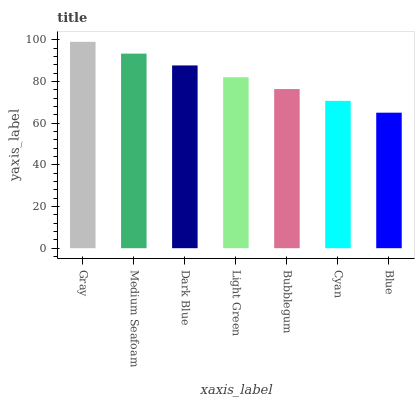Is Medium Seafoam the minimum?
Answer yes or no. No. Is Medium Seafoam the maximum?
Answer yes or no. No. Is Gray greater than Medium Seafoam?
Answer yes or no. Yes. Is Medium Seafoam less than Gray?
Answer yes or no. Yes. Is Medium Seafoam greater than Gray?
Answer yes or no. No. Is Gray less than Medium Seafoam?
Answer yes or no. No. Is Light Green the high median?
Answer yes or no. Yes. Is Light Green the low median?
Answer yes or no. Yes. Is Gray the high median?
Answer yes or no. No. Is Bubblegum the low median?
Answer yes or no. No. 